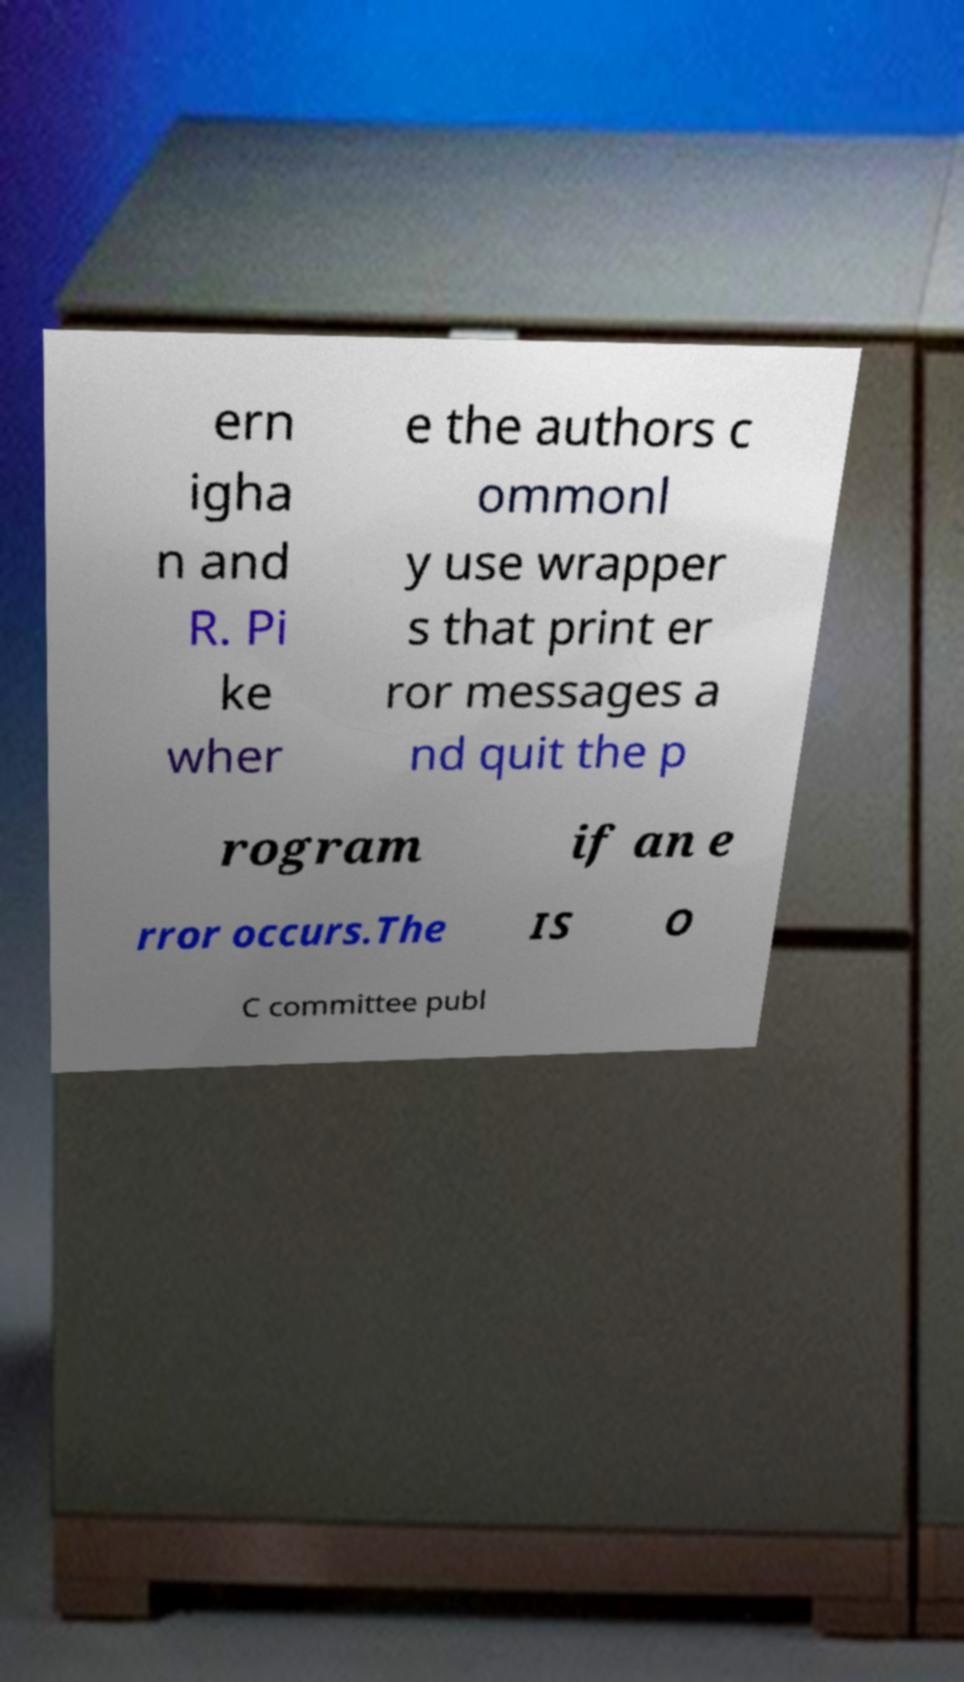What messages or text are displayed in this image? I need them in a readable, typed format. ern igha n and R. Pi ke wher e the authors c ommonl y use wrapper s that print er ror messages a nd quit the p rogram if an e rror occurs.The IS O C committee publ 